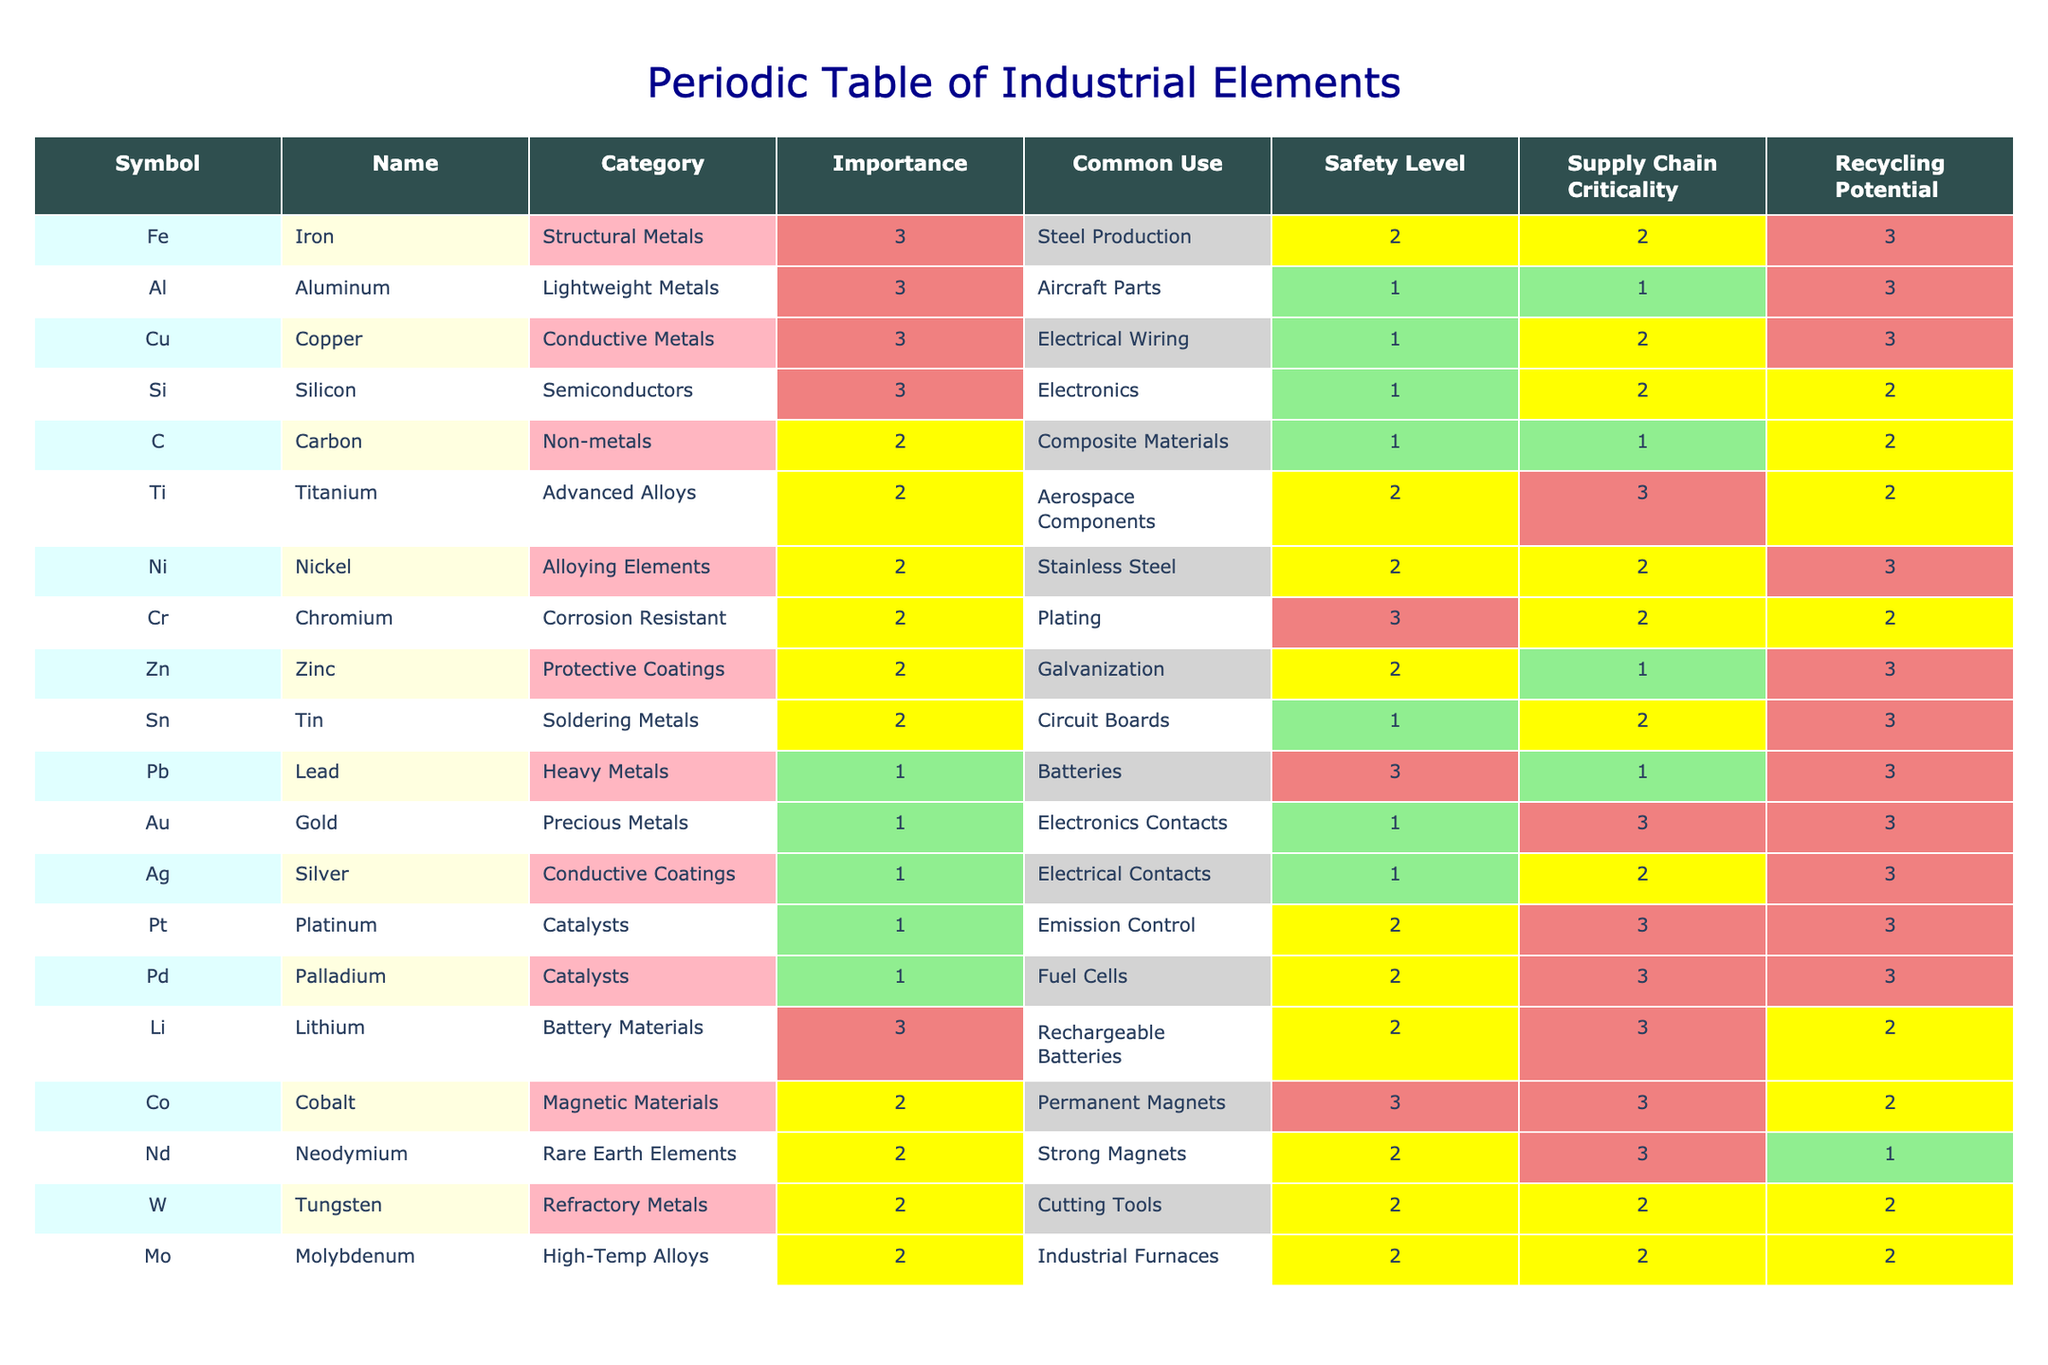What is the most common use for Iron? Referring to the "Common Use" column for Iron (Fe), it is listed as "Steel Production." Therefore, the most common use for Iron is steel production.
Answer: Steel Production Which element has the highest recycling potential? The "Recycling Potential" column indicates that Iron (Fe), Aluminum (Al), Copper (Cu), Zinc (Zn), Tin (Sn), Lead (Pb), Gold (Au), Silver (Ag), and Platinum (Pt) have high potential. Out of these, Iron, Aluminum, Copper, Zinc, Tin, Lead, Gold, Silver, and Platinum all have a high rating in the "Recycling Potential" category.
Answer: Iron, Aluminum, Copper, Zinc, Tin, Lead, Gold, Silver, Platinum Is Carbon classified as a protective coating material? Looking at the "Category" column, Carbon is listed as a non-metal and does not fall into any category that includes protective coatings. Therefore, the statement is false.
Answer: No How many elements are categorized as Conductive Metals? Referring to the "Category" column, Coppe (Cu) and Silver (Ag) are classified as Conductive Metals. Since there are two entries in this category, the total is 2.
Answer: 2 Which element has a medium safety level and high supply chain criticality? We can check the "Safety Level" and "Supply Chain Criticality" columns. Nickel (Ni) has a medium safety level (2) and high supply chain criticality (3). Therefore, Nickel is the element with the specified criteria.
Answer: Nickel What is the average importance value for Advanced Alloys? There is one element under the Advanced Alloys category, which is Titanium (Ti) with a medium importance of 2. Since there is only one data point, the average importance value is 2.
Answer: 2 Does Zinc have a low supply chain criticality? Looking at the "Supply Chain Criticality" column, Zinc (Zn) is listed with a medium level (2), indicating that it does not have a low supply chain criticality. Therefore, the statement is false.
Answer: No Which element has the lowest safety level? Referring to the "Safety Level" column, Lead (Pb) has a high safety level (1), which is the lowest in comparison to others.
Answer: Lead Which metal is primarily used in emission control? The "Common Use" column for Platinum (Pt) indicates that it is primarily used in emission control technologies, making it significant in that application.
Answer: Platinum 